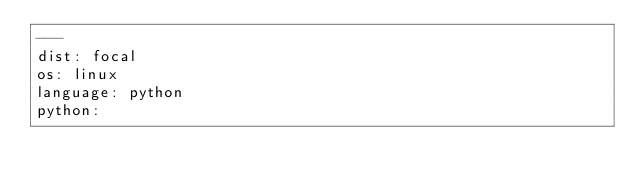Convert code to text. <code><loc_0><loc_0><loc_500><loc_500><_YAML_>---
dist: focal
os: linux
language: python
python:</code> 